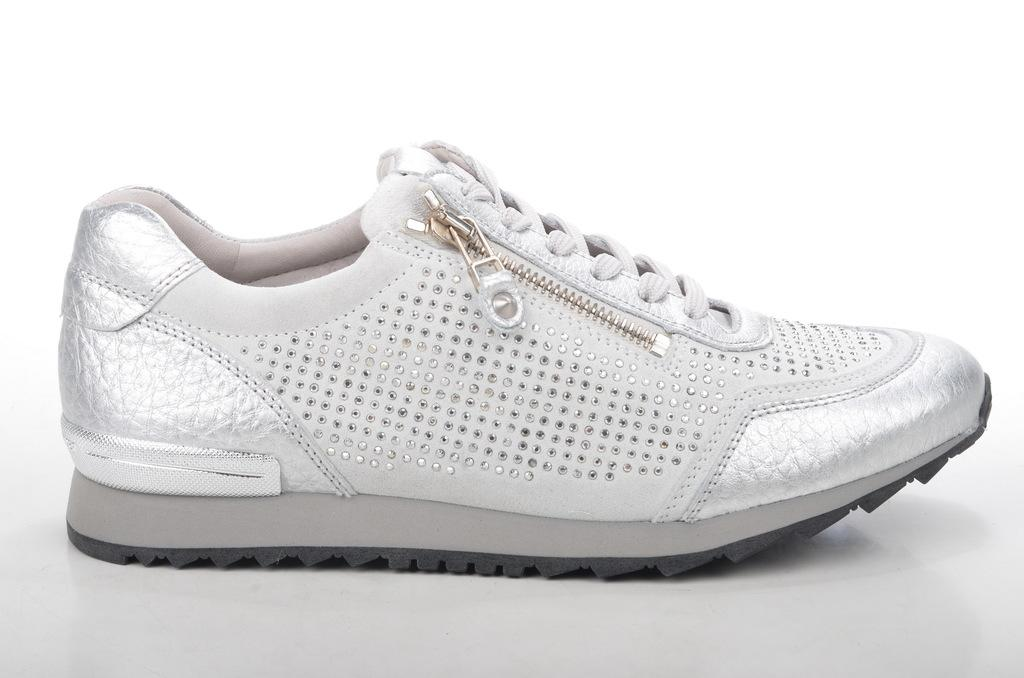What object is the main subject of the picture? There is a shoe in the picture. What is the color of the shoe? The shoe is white in color. Does the shoe have any specific features? Yes, the shoe has a zip. What can be seen in the background of the image? The background of the image is white. What type of chess piece is depicted on the shoe in the image? There is no chess piece depicted on the shoe in the image; it is a regular white shoe with a zip. What can be seen written on the shoe using chalk? There is no writing or chalk visible on the shoe in the image. 